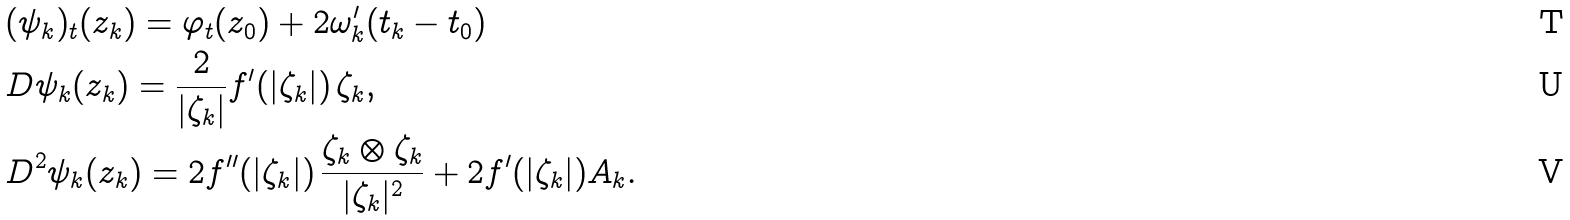Convert formula to latex. <formula><loc_0><loc_0><loc_500><loc_500>& ( \psi _ { k } ) _ { t } ( z _ { k } ) = \varphi _ { t } ( z _ { 0 } ) + 2 \omega ^ { \prime } _ { k } ( t _ { k } - t _ { 0 } ) \\ & D \psi _ { k } ( z _ { k } ) = \frac { 2 } { | \zeta _ { k } | } f ^ { \prime } ( | \zeta _ { k } | ) \, \zeta _ { k } , \\ & D ^ { 2 } \psi _ { k } ( z _ { k } ) = 2 f ^ { \prime \prime } ( | \zeta _ { k } | ) \, \frac { \zeta _ { k } \otimes \zeta _ { k } } { | \zeta _ { k } | ^ { 2 } } + 2 f ^ { \prime } ( | \zeta _ { k } | ) A _ { k } .</formula> 